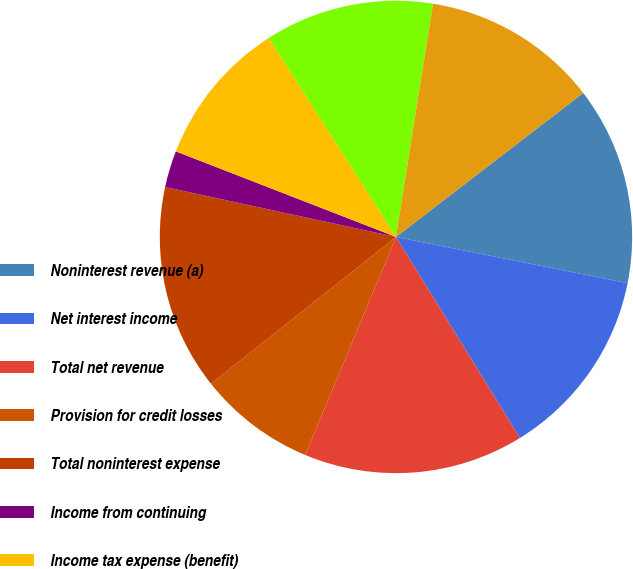Convert chart to OTSL. <chart><loc_0><loc_0><loc_500><loc_500><pie_chart><fcel>Noninterest revenue (a)<fcel>Net interest income<fcel>Total net revenue<fcel>Provision for credit losses<fcel>Total noninterest expense<fcel>Income from continuing<fcel>Income tax expense (benefit)<fcel>Income before extraordinary<fcel>Net income<nl><fcel>13.57%<fcel>13.07%<fcel>15.08%<fcel>8.04%<fcel>14.07%<fcel>2.51%<fcel>10.05%<fcel>11.56%<fcel>12.06%<nl></chart> 